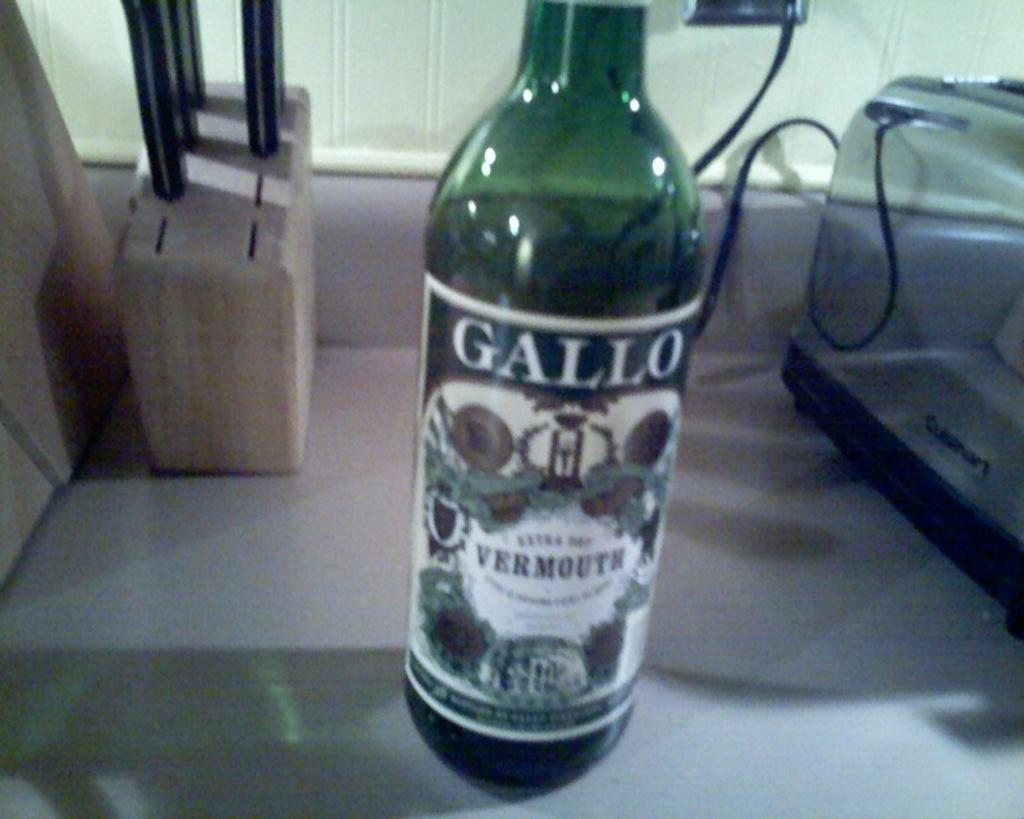What object can be seen in the image that is typically used for holding liquids? There is a bottle in the image. What is on the bottle? The bottle has a sticker on it. What kitchen appliance is visible in the image? There is a toast maker in the image. What is used for storing and organizing knives in the image? There is a knife holder in the image. What type of shoes are being advertised on the company's patch in the image? There is no mention of shoes or a company's patch in the image; it only features a bottle, knife holder, and toast maker. 